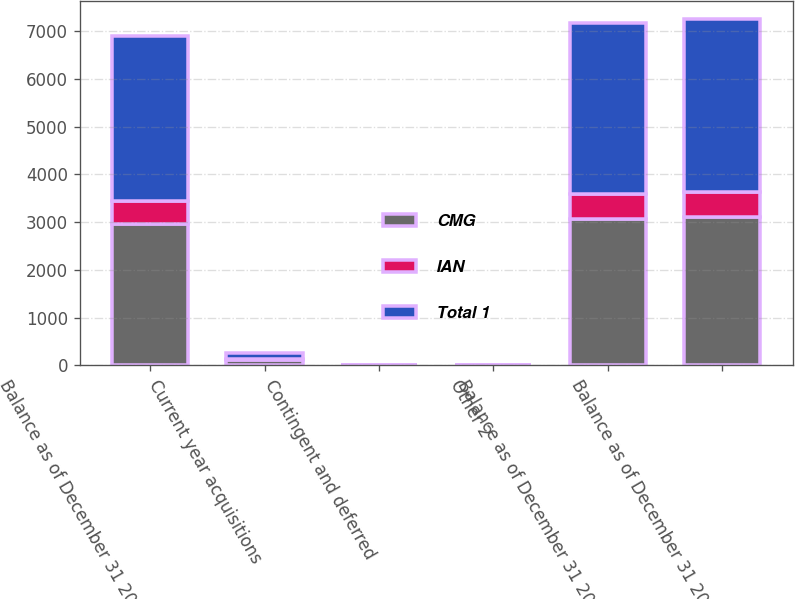<chart> <loc_0><loc_0><loc_500><loc_500><stacked_bar_chart><ecel><fcel>Balance as of December 31 2011<fcel>Current year acquisitions<fcel>Contingent and deferred<fcel>Other 2<fcel>Balance as of December 31 2012<fcel>Balance as of December 31 2013<nl><fcel>CMG<fcel>2952.9<fcel>122<fcel>2.2<fcel>2.5<fcel>3074.6<fcel>3109.3<nl><fcel>IAN<fcel>491.4<fcel>11.7<fcel>0<fcel>2.9<fcel>506<fcel>519.7<nl><fcel>Total 1<fcel>3444.3<fcel>133.7<fcel>2.2<fcel>0.4<fcel>3580.6<fcel>3629<nl></chart> 